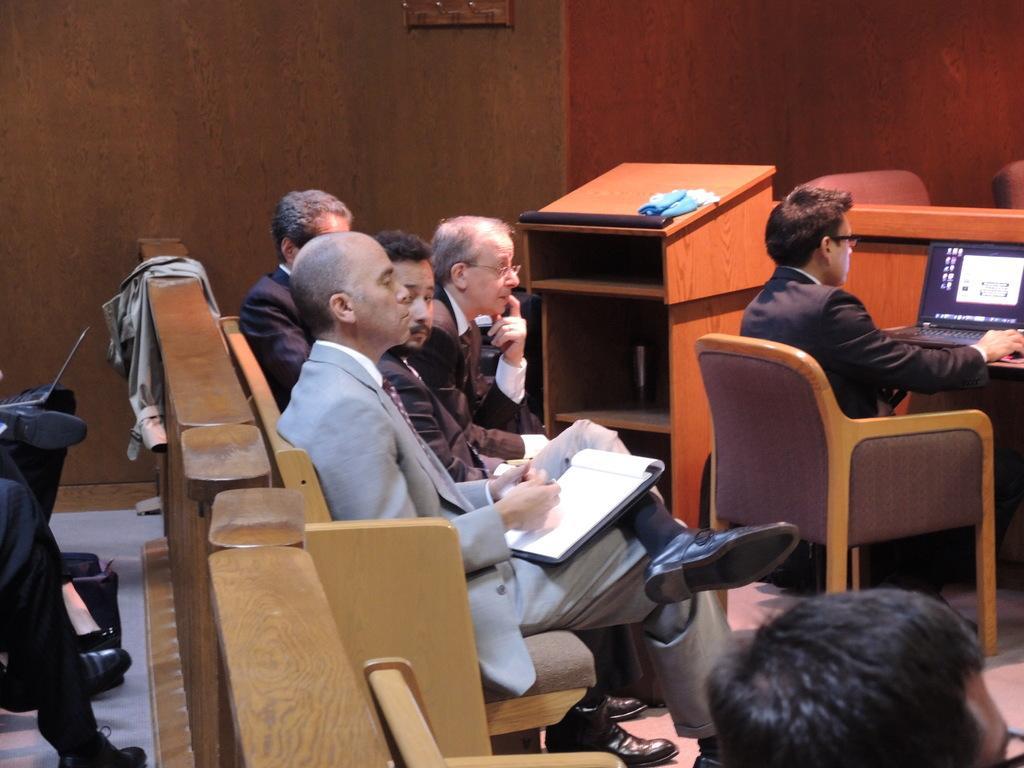Please provide a concise description of this image. This picture is clicked inside the room. Here, we see many people sitting on chair. Man on left corner of the picture wearing black blazer is operating laptop which is placed on table. Beside her, we see a table containing cloth on it and on background, we see brown wall. 